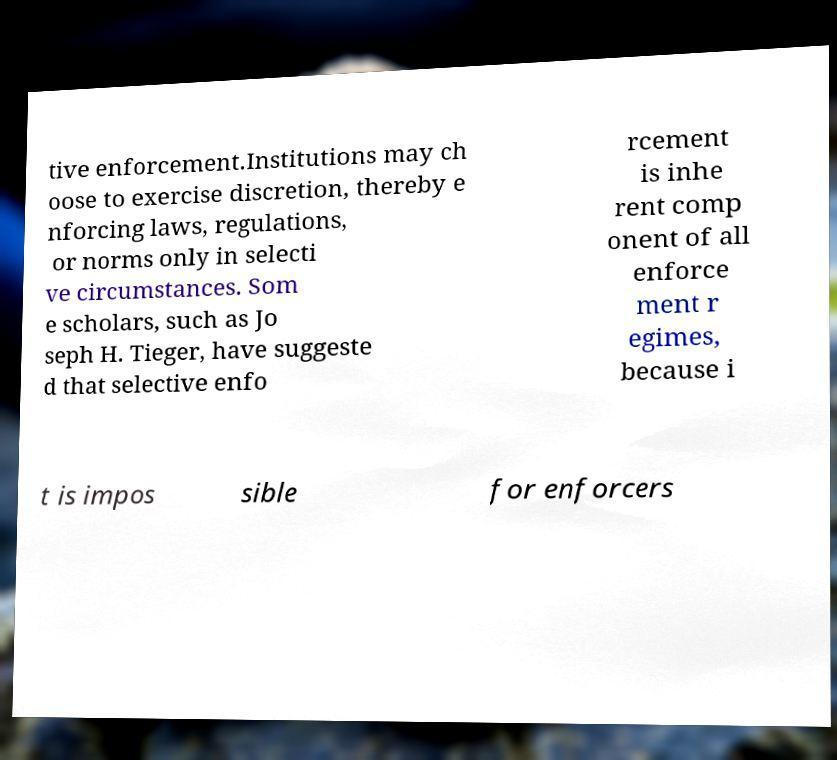For documentation purposes, I need the text within this image transcribed. Could you provide that? tive enforcement.Institutions may ch oose to exercise discretion, thereby e nforcing laws, regulations, or norms only in selecti ve circumstances. Som e scholars, such as Jo seph H. Tieger, have suggeste d that selective enfo rcement is inhe rent comp onent of all enforce ment r egimes, because i t is impos sible for enforcers 